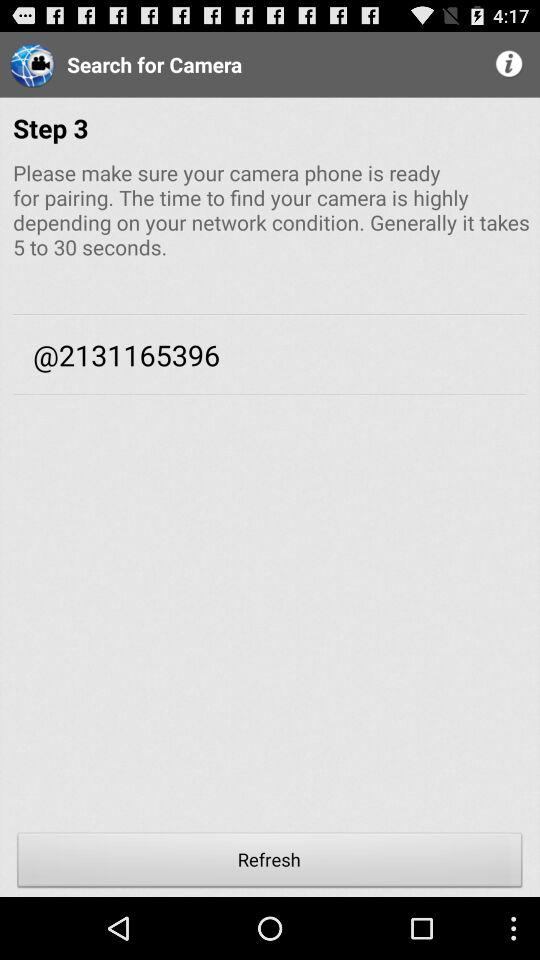How many steps are there to pair the camera?
Answer the question using a single word or phrase. 3 